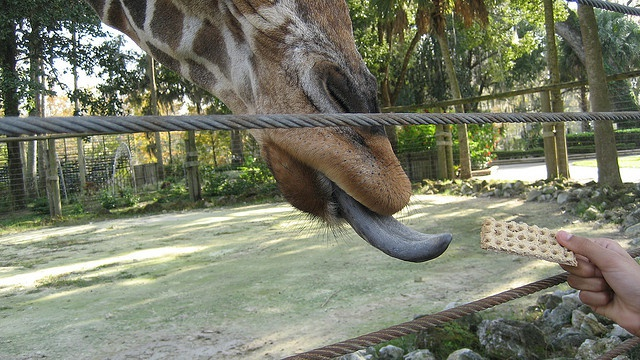Describe the objects in this image and their specific colors. I can see giraffe in black, gray, and darkgray tones and people in black, gray, darkgray, and maroon tones in this image. 